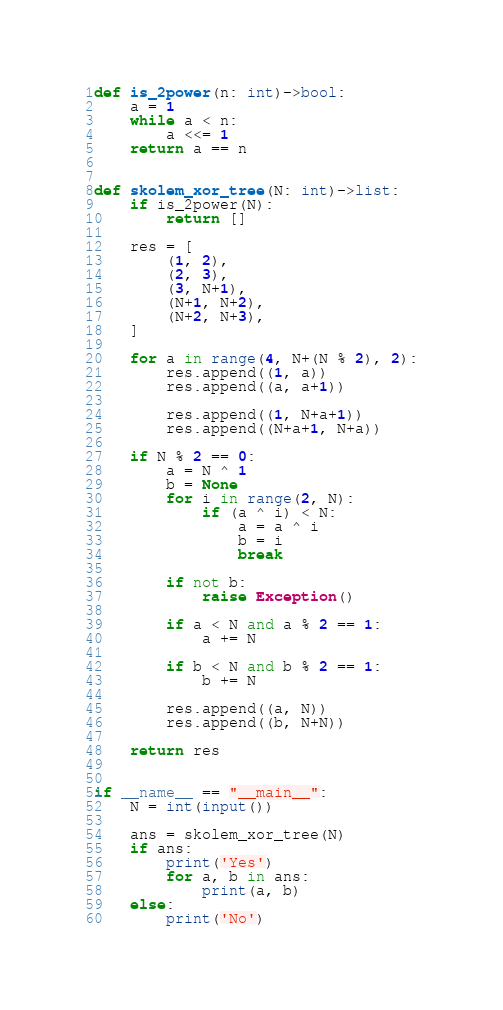Convert code to text. <code><loc_0><loc_0><loc_500><loc_500><_Python_>def is_2power(n: int)->bool:
    a = 1
    while a < n:
        a <<= 1
    return a == n


def skolem_xor_tree(N: int)->list:
    if is_2power(N):
        return []

    res = [
        (1, 2),
        (2, 3),
        (3, N+1),
        (N+1, N+2),
        (N+2, N+3),
    ]

    for a in range(4, N+(N % 2), 2):
        res.append((1, a))
        res.append((a, a+1))

        res.append((1, N+a+1))
        res.append((N+a+1, N+a))

    if N % 2 == 0:
        a = N ^ 1
        b = None
        for i in range(2, N):
            if (a ^ i) < N:
                a = a ^ i
                b = i
                break

        if not b:
            raise Exception()

        if a < N and a % 2 == 1:
            a += N

        if b < N and b % 2 == 1:
            b += N

        res.append((a, N))
        res.append((b, N+N))

    return res


if __name__ == "__main__":
    N = int(input())

    ans = skolem_xor_tree(N)
    if ans:
        print('Yes')
        for a, b in ans:
            print(a, b)
    else:
        print('No')
</code> 